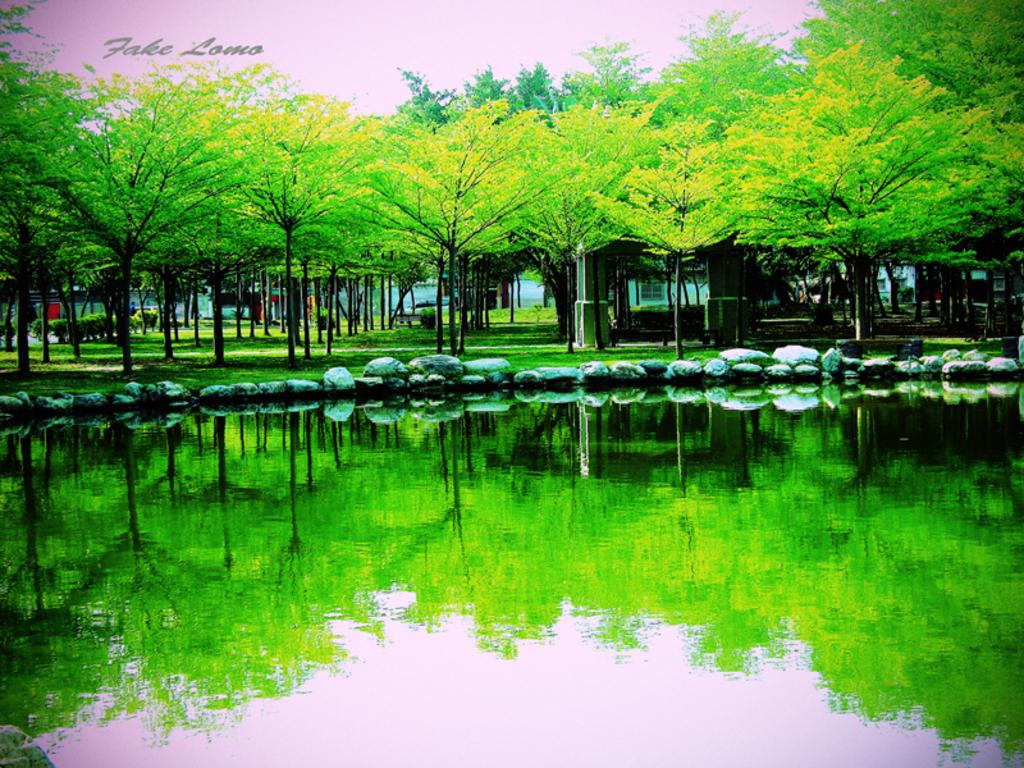What type of editing has been done to the image? The image is edited, but the specific type of editing is not mentioned in the facts. What is located at the bottom of the picture? There is water at the bottom of the picture. What can be seen in the middle of the picture? There are rocks and grass in the middle of the picture. What is visible in the background of the picture? There are trees and buildings in the background of the picture. What type of cloud is depicted in the prose of the image? There is no prose present in the image, and therefore no cloud can be described in relation to it. 